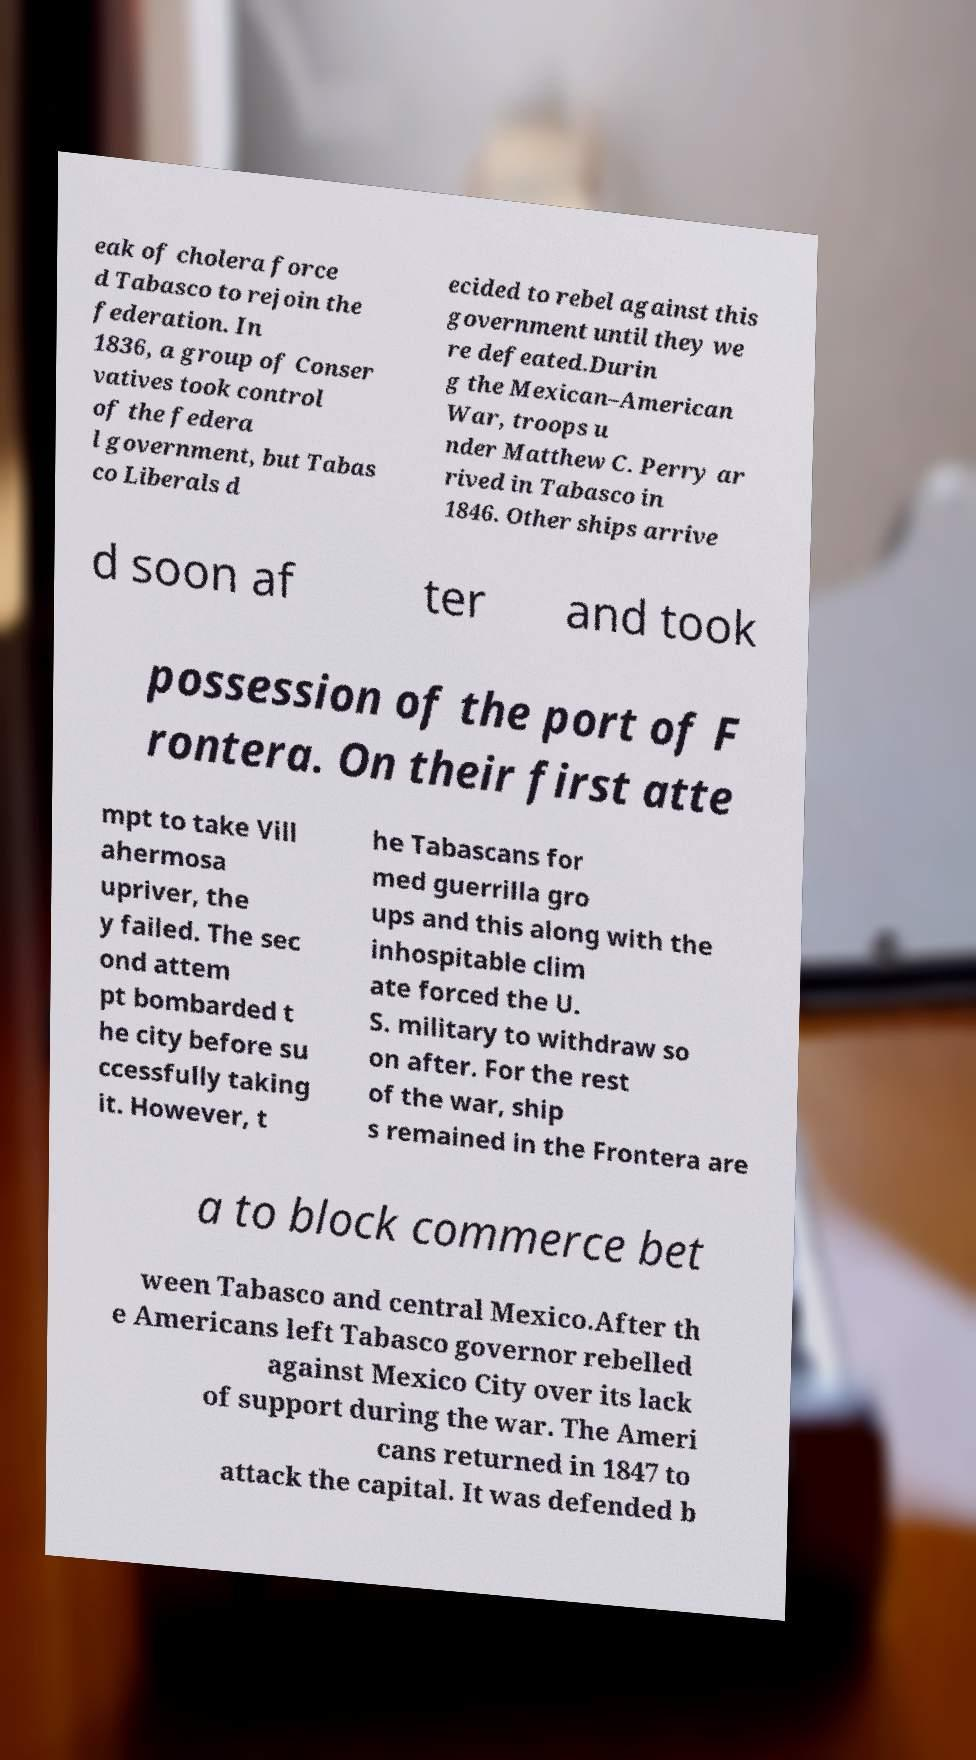Could you assist in decoding the text presented in this image and type it out clearly? eak of cholera force d Tabasco to rejoin the federation. In 1836, a group of Conser vatives took control of the federa l government, but Tabas co Liberals d ecided to rebel against this government until they we re defeated.Durin g the Mexican–American War, troops u nder Matthew C. Perry ar rived in Tabasco in 1846. Other ships arrive d soon af ter and took possession of the port of F rontera. On their first atte mpt to take Vill ahermosa upriver, the y failed. The sec ond attem pt bombarded t he city before su ccessfully taking it. However, t he Tabascans for med guerrilla gro ups and this along with the inhospitable clim ate forced the U. S. military to withdraw so on after. For the rest of the war, ship s remained in the Frontera are a to block commerce bet ween Tabasco and central Mexico.After th e Americans left Tabasco governor rebelled against Mexico City over its lack of support during the war. The Ameri cans returned in 1847 to attack the capital. It was defended b 